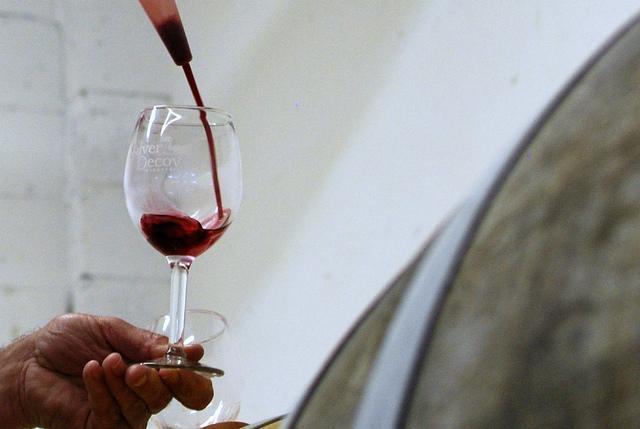How many birds are here?
Give a very brief answer. 0. 